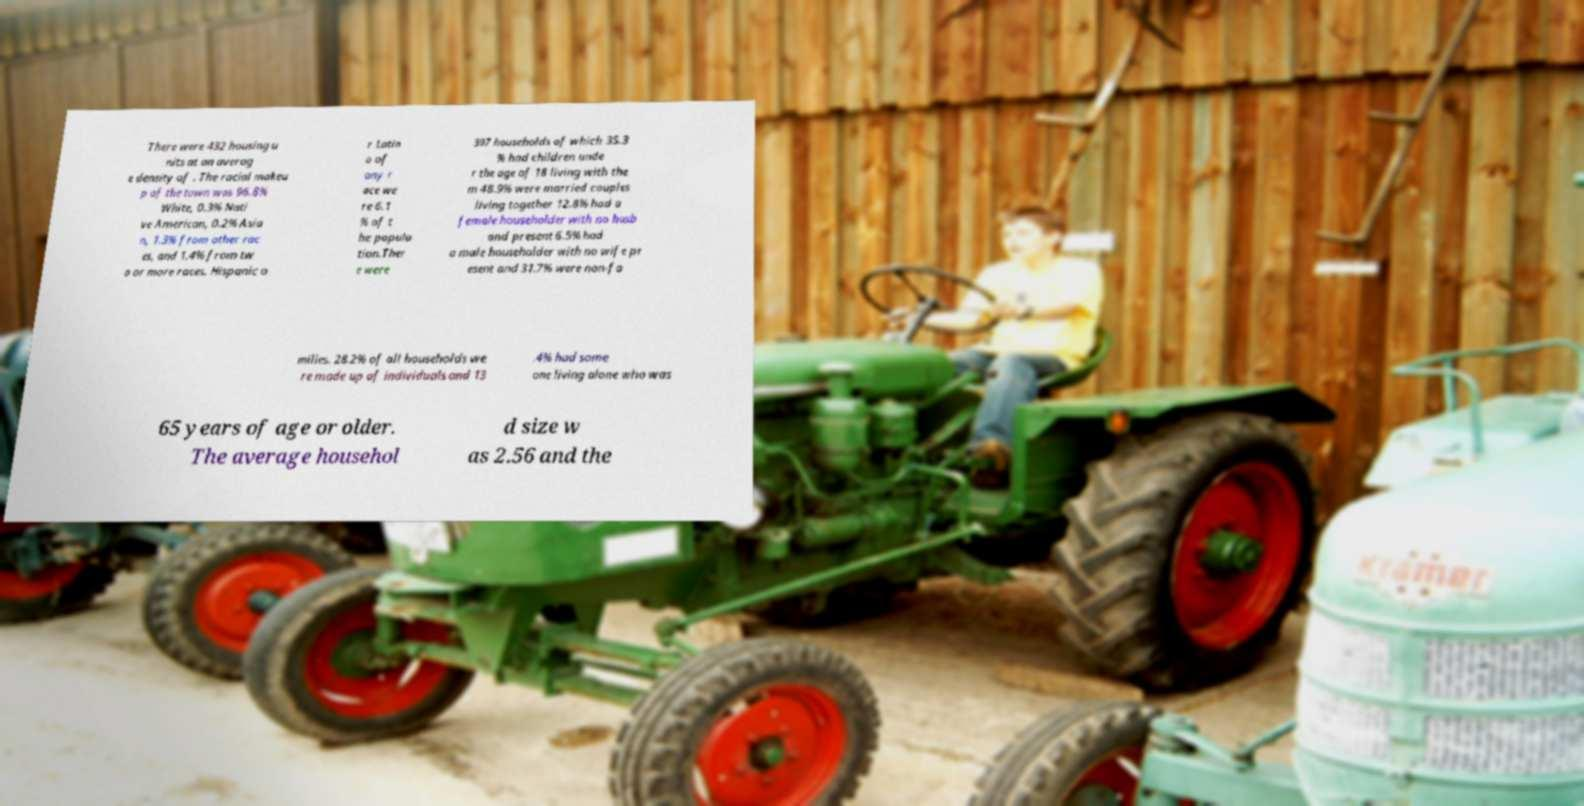Could you extract and type out the text from this image? There were 432 housing u nits at an averag e density of . The racial makeu p of the town was 96.8% White, 0.3% Nati ve American, 0.2% Asia n, 1.3% from other rac es, and 1.4% from tw o or more races. Hispanic o r Latin o of any r ace we re 6.1 % of t he popula tion.Ther e were 397 households of which 35.3 % had children unde r the age of 18 living with the m 48.9% were married couples living together 12.8% had a female householder with no husb and present 6.5% had a male householder with no wife pr esent and 31.7% were non-fa milies. 28.2% of all households we re made up of individuals and 13 .4% had some one living alone who was 65 years of age or older. The average househol d size w as 2.56 and the 